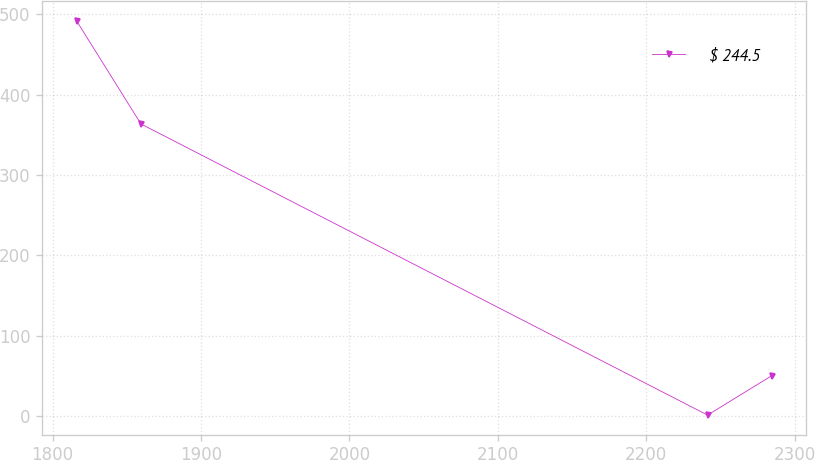<chart> <loc_0><loc_0><loc_500><loc_500><line_chart><ecel><fcel>$ 244.5<nl><fcel>1816.3<fcel>491.69<nl><fcel>1859.52<fcel>363.65<nl><fcel>2241.22<fcel>1.04<nl><fcel>2284.44<fcel>50.1<nl></chart> 